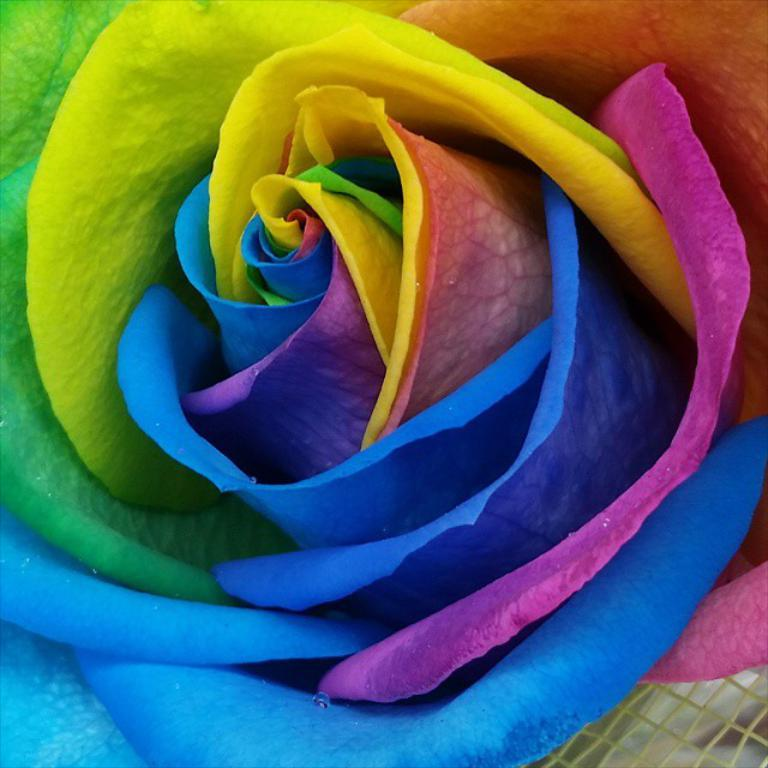What is the appearance of the floor in the image? The floor in the image is multi-colored. Can you describe any specific features in the bottom right corner of the image? There is a mesh in the bottom right corner of the image. Reasoning: Let' Let's think step by step in order to produce the conversation. We start by identifying the main subject in the image, which is the floor. Then, we expand the conversation to include a specific feature in the image, which is the mesh in the bottom right corner. Each question is designed to elicit a specific detail about the image that is known from the provided facts. Absurd Question/Answer: What type of stone can be heard making a voice in the image? There is no stone or voice present in the image. What key is used to unlock the mesh in the image? There is no key or lock present in the image; the mesh is visible but not obstructed. What type of stone can be heard making a voice in the image? There is no stone or voice present in the image. What key is used to unlock the mesh in the image? There is no key or lock present in the image; the mesh is visible but not obstructed. 